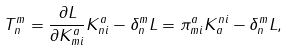<formula> <loc_0><loc_0><loc_500><loc_500>T ^ { m } _ { n } = \frac { \partial L } { \partial K ^ { a } _ { m i } } K ^ { a } _ { n i } - \delta ^ { m } _ { n } L = \pi ^ { a } _ { m i } K ^ { n i } _ { a } - \delta ^ { m } _ { n } L ,</formula> 